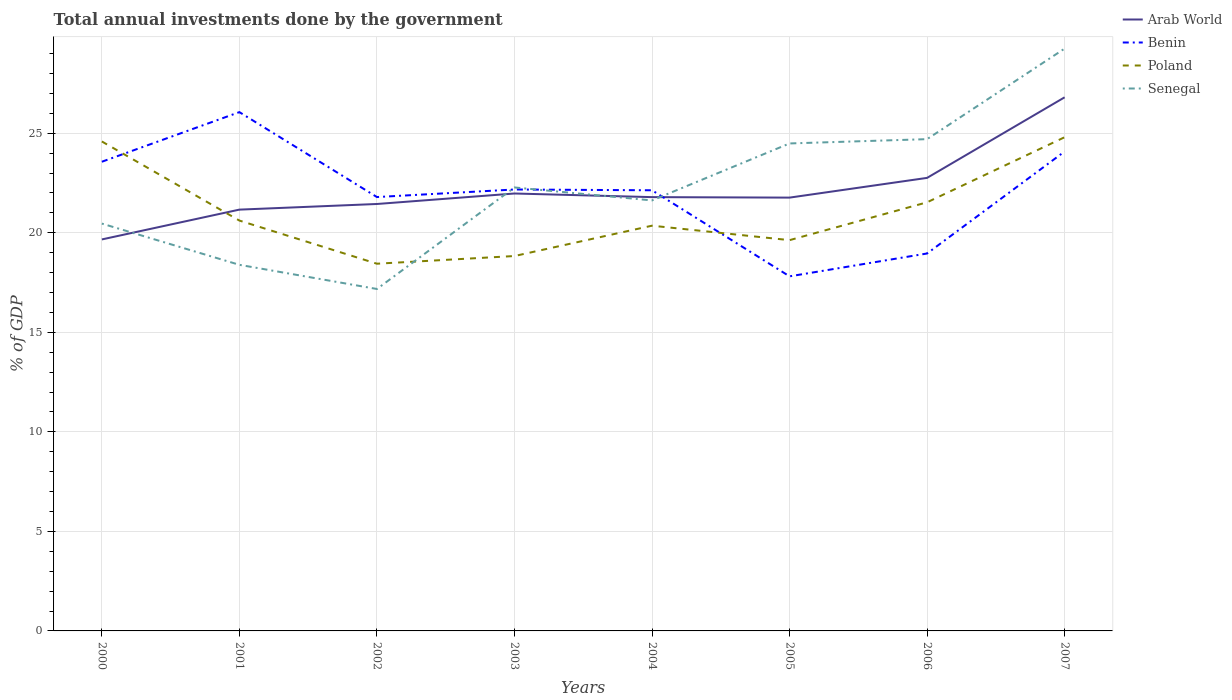Across all years, what is the maximum total annual investments done by the government in Benin?
Offer a very short reply. 17.81. In which year was the total annual investments done by the government in Arab World maximum?
Your answer should be compact. 2000. What is the total total annual investments done by the government in Poland in the graph?
Ensure brevity in your answer.  -3.09. What is the difference between the highest and the second highest total annual investments done by the government in Arab World?
Make the answer very short. 7.14. What is the difference between the highest and the lowest total annual investments done by the government in Senegal?
Offer a terse response. 3. How many years are there in the graph?
Ensure brevity in your answer.  8. What is the difference between two consecutive major ticks on the Y-axis?
Provide a short and direct response. 5. Are the values on the major ticks of Y-axis written in scientific E-notation?
Make the answer very short. No. What is the title of the graph?
Your response must be concise. Total annual investments done by the government. What is the label or title of the X-axis?
Offer a terse response. Years. What is the label or title of the Y-axis?
Your answer should be compact. % of GDP. What is the % of GDP of Arab World in 2000?
Offer a very short reply. 19.67. What is the % of GDP in Benin in 2000?
Ensure brevity in your answer.  23.57. What is the % of GDP of Poland in 2000?
Your response must be concise. 24.59. What is the % of GDP in Senegal in 2000?
Keep it short and to the point. 20.46. What is the % of GDP of Arab World in 2001?
Give a very brief answer. 21.16. What is the % of GDP of Benin in 2001?
Your answer should be compact. 26.06. What is the % of GDP in Poland in 2001?
Provide a short and direct response. 20.61. What is the % of GDP of Senegal in 2001?
Ensure brevity in your answer.  18.39. What is the % of GDP of Arab World in 2002?
Make the answer very short. 21.45. What is the % of GDP of Benin in 2002?
Your answer should be compact. 21.79. What is the % of GDP of Poland in 2002?
Ensure brevity in your answer.  18.45. What is the % of GDP of Senegal in 2002?
Keep it short and to the point. 17.18. What is the % of GDP of Arab World in 2003?
Make the answer very short. 21.97. What is the % of GDP in Benin in 2003?
Provide a short and direct response. 22.17. What is the % of GDP of Poland in 2003?
Keep it short and to the point. 18.83. What is the % of GDP of Senegal in 2003?
Make the answer very short. 22.28. What is the % of GDP in Arab World in 2004?
Offer a very short reply. 21.79. What is the % of GDP in Benin in 2004?
Provide a short and direct response. 22.13. What is the % of GDP of Poland in 2004?
Your response must be concise. 20.36. What is the % of GDP in Senegal in 2004?
Provide a short and direct response. 21.63. What is the % of GDP of Arab World in 2005?
Ensure brevity in your answer.  21.77. What is the % of GDP of Benin in 2005?
Give a very brief answer. 17.81. What is the % of GDP of Poland in 2005?
Keep it short and to the point. 19.63. What is the % of GDP of Senegal in 2005?
Give a very brief answer. 24.49. What is the % of GDP in Arab World in 2006?
Your response must be concise. 22.76. What is the % of GDP of Benin in 2006?
Provide a short and direct response. 18.96. What is the % of GDP in Poland in 2006?
Keep it short and to the point. 21.53. What is the % of GDP in Senegal in 2006?
Your response must be concise. 24.7. What is the % of GDP of Arab World in 2007?
Your response must be concise. 26.8. What is the % of GDP of Benin in 2007?
Your response must be concise. 24.08. What is the % of GDP in Poland in 2007?
Provide a succinct answer. 24.8. What is the % of GDP of Senegal in 2007?
Your answer should be very brief. 29.25. Across all years, what is the maximum % of GDP of Arab World?
Ensure brevity in your answer.  26.8. Across all years, what is the maximum % of GDP of Benin?
Your response must be concise. 26.06. Across all years, what is the maximum % of GDP in Poland?
Offer a very short reply. 24.8. Across all years, what is the maximum % of GDP in Senegal?
Offer a terse response. 29.25. Across all years, what is the minimum % of GDP in Arab World?
Give a very brief answer. 19.67. Across all years, what is the minimum % of GDP in Benin?
Provide a succinct answer. 17.81. Across all years, what is the minimum % of GDP of Poland?
Give a very brief answer. 18.45. Across all years, what is the minimum % of GDP of Senegal?
Your answer should be compact. 17.18. What is the total % of GDP of Arab World in the graph?
Offer a terse response. 177.36. What is the total % of GDP of Benin in the graph?
Give a very brief answer. 176.58. What is the total % of GDP in Poland in the graph?
Give a very brief answer. 168.79. What is the total % of GDP of Senegal in the graph?
Provide a succinct answer. 178.37. What is the difference between the % of GDP in Arab World in 2000 and that in 2001?
Provide a short and direct response. -1.5. What is the difference between the % of GDP of Benin in 2000 and that in 2001?
Offer a terse response. -2.49. What is the difference between the % of GDP of Poland in 2000 and that in 2001?
Your answer should be very brief. 3.97. What is the difference between the % of GDP of Senegal in 2000 and that in 2001?
Offer a terse response. 2.07. What is the difference between the % of GDP in Arab World in 2000 and that in 2002?
Ensure brevity in your answer.  -1.78. What is the difference between the % of GDP in Benin in 2000 and that in 2002?
Provide a succinct answer. 1.77. What is the difference between the % of GDP of Poland in 2000 and that in 2002?
Keep it short and to the point. 6.14. What is the difference between the % of GDP of Senegal in 2000 and that in 2002?
Give a very brief answer. 3.29. What is the difference between the % of GDP in Arab World in 2000 and that in 2003?
Offer a very short reply. -2.31. What is the difference between the % of GDP of Benin in 2000 and that in 2003?
Offer a terse response. 1.39. What is the difference between the % of GDP in Poland in 2000 and that in 2003?
Your answer should be very brief. 5.75. What is the difference between the % of GDP in Senegal in 2000 and that in 2003?
Make the answer very short. -1.81. What is the difference between the % of GDP of Arab World in 2000 and that in 2004?
Your answer should be compact. -2.12. What is the difference between the % of GDP of Benin in 2000 and that in 2004?
Your response must be concise. 1.43. What is the difference between the % of GDP in Poland in 2000 and that in 2004?
Your answer should be compact. 4.23. What is the difference between the % of GDP of Senegal in 2000 and that in 2004?
Offer a very short reply. -1.16. What is the difference between the % of GDP in Arab World in 2000 and that in 2005?
Ensure brevity in your answer.  -2.1. What is the difference between the % of GDP in Benin in 2000 and that in 2005?
Your response must be concise. 5.76. What is the difference between the % of GDP of Poland in 2000 and that in 2005?
Ensure brevity in your answer.  4.96. What is the difference between the % of GDP in Senegal in 2000 and that in 2005?
Your answer should be compact. -4.03. What is the difference between the % of GDP in Arab World in 2000 and that in 2006?
Make the answer very short. -3.09. What is the difference between the % of GDP in Benin in 2000 and that in 2006?
Make the answer very short. 4.61. What is the difference between the % of GDP in Poland in 2000 and that in 2006?
Offer a very short reply. 3.06. What is the difference between the % of GDP in Senegal in 2000 and that in 2006?
Provide a short and direct response. -4.24. What is the difference between the % of GDP in Arab World in 2000 and that in 2007?
Provide a short and direct response. -7.14. What is the difference between the % of GDP in Benin in 2000 and that in 2007?
Your answer should be compact. -0.51. What is the difference between the % of GDP of Poland in 2000 and that in 2007?
Keep it short and to the point. -0.21. What is the difference between the % of GDP in Senegal in 2000 and that in 2007?
Your answer should be compact. -8.79. What is the difference between the % of GDP of Arab World in 2001 and that in 2002?
Provide a succinct answer. -0.28. What is the difference between the % of GDP of Benin in 2001 and that in 2002?
Your response must be concise. 4.27. What is the difference between the % of GDP of Poland in 2001 and that in 2002?
Offer a very short reply. 2.17. What is the difference between the % of GDP of Senegal in 2001 and that in 2002?
Keep it short and to the point. 1.21. What is the difference between the % of GDP of Arab World in 2001 and that in 2003?
Offer a terse response. -0.81. What is the difference between the % of GDP of Benin in 2001 and that in 2003?
Offer a terse response. 3.89. What is the difference between the % of GDP of Poland in 2001 and that in 2003?
Your answer should be very brief. 1.78. What is the difference between the % of GDP of Senegal in 2001 and that in 2003?
Ensure brevity in your answer.  -3.89. What is the difference between the % of GDP in Arab World in 2001 and that in 2004?
Keep it short and to the point. -0.63. What is the difference between the % of GDP of Benin in 2001 and that in 2004?
Keep it short and to the point. 3.93. What is the difference between the % of GDP in Poland in 2001 and that in 2004?
Ensure brevity in your answer.  0.26. What is the difference between the % of GDP of Senegal in 2001 and that in 2004?
Ensure brevity in your answer.  -3.24. What is the difference between the % of GDP of Arab World in 2001 and that in 2005?
Provide a succinct answer. -0.6. What is the difference between the % of GDP of Benin in 2001 and that in 2005?
Make the answer very short. 8.25. What is the difference between the % of GDP of Poland in 2001 and that in 2005?
Provide a short and direct response. 0.98. What is the difference between the % of GDP in Senegal in 2001 and that in 2005?
Offer a terse response. -6.1. What is the difference between the % of GDP of Arab World in 2001 and that in 2006?
Keep it short and to the point. -1.59. What is the difference between the % of GDP of Benin in 2001 and that in 2006?
Offer a terse response. 7.1. What is the difference between the % of GDP of Poland in 2001 and that in 2006?
Offer a terse response. -0.92. What is the difference between the % of GDP of Senegal in 2001 and that in 2006?
Keep it short and to the point. -6.31. What is the difference between the % of GDP of Arab World in 2001 and that in 2007?
Your response must be concise. -5.64. What is the difference between the % of GDP of Benin in 2001 and that in 2007?
Give a very brief answer. 1.98. What is the difference between the % of GDP in Poland in 2001 and that in 2007?
Provide a short and direct response. -4.19. What is the difference between the % of GDP of Senegal in 2001 and that in 2007?
Give a very brief answer. -10.86. What is the difference between the % of GDP in Arab World in 2002 and that in 2003?
Offer a terse response. -0.53. What is the difference between the % of GDP in Benin in 2002 and that in 2003?
Provide a succinct answer. -0.38. What is the difference between the % of GDP of Poland in 2002 and that in 2003?
Offer a terse response. -0.39. What is the difference between the % of GDP of Senegal in 2002 and that in 2003?
Keep it short and to the point. -5.1. What is the difference between the % of GDP in Arab World in 2002 and that in 2004?
Offer a very short reply. -0.34. What is the difference between the % of GDP in Benin in 2002 and that in 2004?
Give a very brief answer. -0.34. What is the difference between the % of GDP of Poland in 2002 and that in 2004?
Your answer should be compact. -1.91. What is the difference between the % of GDP in Senegal in 2002 and that in 2004?
Make the answer very short. -4.45. What is the difference between the % of GDP in Arab World in 2002 and that in 2005?
Your response must be concise. -0.32. What is the difference between the % of GDP of Benin in 2002 and that in 2005?
Provide a succinct answer. 3.98. What is the difference between the % of GDP in Poland in 2002 and that in 2005?
Your answer should be very brief. -1.18. What is the difference between the % of GDP of Senegal in 2002 and that in 2005?
Your answer should be very brief. -7.31. What is the difference between the % of GDP of Arab World in 2002 and that in 2006?
Give a very brief answer. -1.31. What is the difference between the % of GDP of Benin in 2002 and that in 2006?
Your answer should be very brief. 2.83. What is the difference between the % of GDP in Poland in 2002 and that in 2006?
Offer a very short reply. -3.09. What is the difference between the % of GDP of Senegal in 2002 and that in 2006?
Make the answer very short. -7.53. What is the difference between the % of GDP in Arab World in 2002 and that in 2007?
Offer a very short reply. -5.36. What is the difference between the % of GDP of Benin in 2002 and that in 2007?
Keep it short and to the point. -2.29. What is the difference between the % of GDP in Poland in 2002 and that in 2007?
Keep it short and to the point. -6.35. What is the difference between the % of GDP of Senegal in 2002 and that in 2007?
Provide a succinct answer. -12.08. What is the difference between the % of GDP in Arab World in 2003 and that in 2004?
Provide a succinct answer. 0.18. What is the difference between the % of GDP in Benin in 2003 and that in 2004?
Offer a very short reply. 0.04. What is the difference between the % of GDP in Poland in 2003 and that in 2004?
Provide a succinct answer. -1.52. What is the difference between the % of GDP in Senegal in 2003 and that in 2004?
Provide a succinct answer. 0.65. What is the difference between the % of GDP of Arab World in 2003 and that in 2005?
Keep it short and to the point. 0.21. What is the difference between the % of GDP in Benin in 2003 and that in 2005?
Keep it short and to the point. 4.36. What is the difference between the % of GDP in Poland in 2003 and that in 2005?
Make the answer very short. -0.8. What is the difference between the % of GDP in Senegal in 2003 and that in 2005?
Provide a short and direct response. -2.21. What is the difference between the % of GDP in Arab World in 2003 and that in 2006?
Give a very brief answer. -0.78. What is the difference between the % of GDP in Benin in 2003 and that in 2006?
Ensure brevity in your answer.  3.21. What is the difference between the % of GDP in Poland in 2003 and that in 2006?
Provide a succinct answer. -2.7. What is the difference between the % of GDP in Senegal in 2003 and that in 2006?
Offer a terse response. -2.43. What is the difference between the % of GDP in Arab World in 2003 and that in 2007?
Offer a terse response. -4.83. What is the difference between the % of GDP of Benin in 2003 and that in 2007?
Provide a short and direct response. -1.91. What is the difference between the % of GDP of Poland in 2003 and that in 2007?
Ensure brevity in your answer.  -5.97. What is the difference between the % of GDP of Senegal in 2003 and that in 2007?
Make the answer very short. -6.98. What is the difference between the % of GDP of Arab World in 2004 and that in 2005?
Your response must be concise. 0.02. What is the difference between the % of GDP in Benin in 2004 and that in 2005?
Give a very brief answer. 4.32. What is the difference between the % of GDP of Poland in 2004 and that in 2005?
Your answer should be compact. 0.73. What is the difference between the % of GDP of Senegal in 2004 and that in 2005?
Give a very brief answer. -2.86. What is the difference between the % of GDP of Arab World in 2004 and that in 2006?
Provide a short and direct response. -0.97. What is the difference between the % of GDP of Benin in 2004 and that in 2006?
Your response must be concise. 3.17. What is the difference between the % of GDP of Poland in 2004 and that in 2006?
Your answer should be very brief. -1.18. What is the difference between the % of GDP in Senegal in 2004 and that in 2006?
Your answer should be compact. -3.08. What is the difference between the % of GDP in Arab World in 2004 and that in 2007?
Provide a succinct answer. -5.01. What is the difference between the % of GDP of Benin in 2004 and that in 2007?
Keep it short and to the point. -1.95. What is the difference between the % of GDP of Poland in 2004 and that in 2007?
Ensure brevity in your answer.  -4.44. What is the difference between the % of GDP in Senegal in 2004 and that in 2007?
Provide a short and direct response. -7.63. What is the difference between the % of GDP in Arab World in 2005 and that in 2006?
Make the answer very short. -0.99. What is the difference between the % of GDP in Benin in 2005 and that in 2006?
Make the answer very short. -1.15. What is the difference between the % of GDP in Poland in 2005 and that in 2006?
Ensure brevity in your answer.  -1.9. What is the difference between the % of GDP of Senegal in 2005 and that in 2006?
Give a very brief answer. -0.22. What is the difference between the % of GDP in Arab World in 2005 and that in 2007?
Your response must be concise. -5.04. What is the difference between the % of GDP in Benin in 2005 and that in 2007?
Make the answer very short. -6.27. What is the difference between the % of GDP in Poland in 2005 and that in 2007?
Provide a short and direct response. -5.17. What is the difference between the % of GDP of Senegal in 2005 and that in 2007?
Your response must be concise. -4.76. What is the difference between the % of GDP in Arab World in 2006 and that in 2007?
Offer a very short reply. -4.05. What is the difference between the % of GDP in Benin in 2006 and that in 2007?
Offer a very short reply. -5.12. What is the difference between the % of GDP of Poland in 2006 and that in 2007?
Make the answer very short. -3.27. What is the difference between the % of GDP of Senegal in 2006 and that in 2007?
Make the answer very short. -4.55. What is the difference between the % of GDP in Arab World in 2000 and the % of GDP in Benin in 2001?
Your response must be concise. -6.39. What is the difference between the % of GDP in Arab World in 2000 and the % of GDP in Poland in 2001?
Provide a succinct answer. -0.95. What is the difference between the % of GDP in Arab World in 2000 and the % of GDP in Senegal in 2001?
Keep it short and to the point. 1.28. What is the difference between the % of GDP of Benin in 2000 and the % of GDP of Poland in 2001?
Your answer should be very brief. 2.95. What is the difference between the % of GDP of Benin in 2000 and the % of GDP of Senegal in 2001?
Make the answer very short. 5.18. What is the difference between the % of GDP in Poland in 2000 and the % of GDP in Senegal in 2001?
Ensure brevity in your answer.  6.2. What is the difference between the % of GDP of Arab World in 2000 and the % of GDP of Benin in 2002?
Your answer should be compact. -2.13. What is the difference between the % of GDP in Arab World in 2000 and the % of GDP in Poland in 2002?
Keep it short and to the point. 1.22. What is the difference between the % of GDP in Arab World in 2000 and the % of GDP in Senegal in 2002?
Make the answer very short. 2.49. What is the difference between the % of GDP in Benin in 2000 and the % of GDP in Poland in 2002?
Provide a short and direct response. 5.12. What is the difference between the % of GDP in Benin in 2000 and the % of GDP in Senegal in 2002?
Your answer should be compact. 6.39. What is the difference between the % of GDP in Poland in 2000 and the % of GDP in Senegal in 2002?
Your response must be concise. 7.41. What is the difference between the % of GDP of Arab World in 2000 and the % of GDP of Benin in 2003?
Your answer should be very brief. -2.51. What is the difference between the % of GDP of Arab World in 2000 and the % of GDP of Poland in 2003?
Ensure brevity in your answer.  0.83. What is the difference between the % of GDP of Arab World in 2000 and the % of GDP of Senegal in 2003?
Provide a short and direct response. -2.61. What is the difference between the % of GDP in Benin in 2000 and the % of GDP in Poland in 2003?
Your response must be concise. 4.74. What is the difference between the % of GDP of Benin in 2000 and the % of GDP of Senegal in 2003?
Offer a very short reply. 1.29. What is the difference between the % of GDP of Poland in 2000 and the % of GDP of Senegal in 2003?
Your response must be concise. 2.31. What is the difference between the % of GDP of Arab World in 2000 and the % of GDP of Benin in 2004?
Make the answer very short. -2.47. What is the difference between the % of GDP of Arab World in 2000 and the % of GDP of Poland in 2004?
Your answer should be compact. -0.69. What is the difference between the % of GDP of Arab World in 2000 and the % of GDP of Senegal in 2004?
Offer a terse response. -1.96. What is the difference between the % of GDP in Benin in 2000 and the % of GDP in Poland in 2004?
Make the answer very short. 3.21. What is the difference between the % of GDP in Benin in 2000 and the % of GDP in Senegal in 2004?
Make the answer very short. 1.94. What is the difference between the % of GDP of Poland in 2000 and the % of GDP of Senegal in 2004?
Give a very brief answer. 2.96. What is the difference between the % of GDP of Arab World in 2000 and the % of GDP of Benin in 2005?
Offer a terse response. 1.85. What is the difference between the % of GDP of Arab World in 2000 and the % of GDP of Poland in 2005?
Keep it short and to the point. 0.04. What is the difference between the % of GDP in Arab World in 2000 and the % of GDP in Senegal in 2005?
Your response must be concise. -4.82. What is the difference between the % of GDP in Benin in 2000 and the % of GDP in Poland in 2005?
Keep it short and to the point. 3.94. What is the difference between the % of GDP of Benin in 2000 and the % of GDP of Senegal in 2005?
Your answer should be compact. -0.92. What is the difference between the % of GDP of Poland in 2000 and the % of GDP of Senegal in 2005?
Provide a short and direct response. 0.1. What is the difference between the % of GDP of Arab World in 2000 and the % of GDP of Benin in 2006?
Your response must be concise. 0.71. What is the difference between the % of GDP of Arab World in 2000 and the % of GDP of Poland in 2006?
Provide a short and direct response. -1.87. What is the difference between the % of GDP of Arab World in 2000 and the % of GDP of Senegal in 2006?
Offer a very short reply. -5.04. What is the difference between the % of GDP of Benin in 2000 and the % of GDP of Poland in 2006?
Make the answer very short. 2.04. What is the difference between the % of GDP in Benin in 2000 and the % of GDP in Senegal in 2006?
Your response must be concise. -1.14. What is the difference between the % of GDP of Poland in 2000 and the % of GDP of Senegal in 2006?
Your answer should be compact. -0.12. What is the difference between the % of GDP of Arab World in 2000 and the % of GDP of Benin in 2007?
Your response must be concise. -4.42. What is the difference between the % of GDP in Arab World in 2000 and the % of GDP in Poland in 2007?
Give a very brief answer. -5.13. What is the difference between the % of GDP of Arab World in 2000 and the % of GDP of Senegal in 2007?
Give a very brief answer. -9.59. What is the difference between the % of GDP of Benin in 2000 and the % of GDP of Poland in 2007?
Your answer should be very brief. -1.23. What is the difference between the % of GDP of Benin in 2000 and the % of GDP of Senegal in 2007?
Offer a very short reply. -5.68. What is the difference between the % of GDP of Poland in 2000 and the % of GDP of Senegal in 2007?
Your response must be concise. -4.67. What is the difference between the % of GDP of Arab World in 2001 and the % of GDP of Benin in 2002?
Your answer should be very brief. -0.63. What is the difference between the % of GDP in Arab World in 2001 and the % of GDP in Poland in 2002?
Ensure brevity in your answer.  2.72. What is the difference between the % of GDP of Arab World in 2001 and the % of GDP of Senegal in 2002?
Your answer should be very brief. 3.99. What is the difference between the % of GDP in Benin in 2001 and the % of GDP in Poland in 2002?
Make the answer very short. 7.61. What is the difference between the % of GDP of Benin in 2001 and the % of GDP of Senegal in 2002?
Offer a terse response. 8.88. What is the difference between the % of GDP in Poland in 2001 and the % of GDP in Senegal in 2002?
Your answer should be compact. 3.44. What is the difference between the % of GDP in Arab World in 2001 and the % of GDP in Benin in 2003?
Make the answer very short. -1.01. What is the difference between the % of GDP in Arab World in 2001 and the % of GDP in Poland in 2003?
Your answer should be compact. 2.33. What is the difference between the % of GDP in Arab World in 2001 and the % of GDP in Senegal in 2003?
Provide a succinct answer. -1.11. What is the difference between the % of GDP of Benin in 2001 and the % of GDP of Poland in 2003?
Make the answer very short. 7.23. What is the difference between the % of GDP of Benin in 2001 and the % of GDP of Senegal in 2003?
Your response must be concise. 3.78. What is the difference between the % of GDP in Poland in 2001 and the % of GDP in Senegal in 2003?
Give a very brief answer. -1.66. What is the difference between the % of GDP in Arab World in 2001 and the % of GDP in Benin in 2004?
Give a very brief answer. -0.97. What is the difference between the % of GDP of Arab World in 2001 and the % of GDP of Poland in 2004?
Your answer should be compact. 0.81. What is the difference between the % of GDP of Arab World in 2001 and the % of GDP of Senegal in 2004?
Keep it short and to the point. -0.46. What is the difference between the % of GDP in Benin in 2001 and the % of GDP in Poland in 2004?
Give a very brief answer. 5.7. What is the difference between the % of GDP of Benin in 2001 and the % of GDP of Senegal in 2004?
Your answer should be compact. 4.43. What is the difference between the % of GDP of Poland in 2001 and the % of GDP of Senegal in 2004?
Your response must be concise. -1.01. What is the difference between the % of GDP in Arab World in 2001 and the % of GDP in Benin in 2005?
Provide a succinct answer. 3.35. What is the difference between the % of GDP of Arab World in 2001 and the % of GDP of Poland in 2005?
Offer a terse response. 1.53. What is the difference between the % of GDP of Arab World in 2001 and the % of GDP of Senegal in 2005?
Provide a succinct answer. -3.32. What is the difference between the % of GDP in Benin in 2001 and the % of GDP in Poland in 2005?
Your answer should be very brief. 6.43. What is the difference between the % of GDP of Benin in 2001 and the % of GDP of Senegal in 2005?
Keep it short and to the point. 1.57. What is the difference between the % of GDP of Poland in 2001 and the % of GDP of Senegal in 2005?
Ensure brevity in your answer.  -3.87. What is the difference between the % of GDP of Arab World in 2001 and the % of GDP of Benin in 2006?
Ensure brevity in your answer.  2.2. What is the difference between the % of GDP of Arab World in 2001 and the % of GDP of Poland in 2006?
Your answer should be compact. -0.37. What is the difference between the % of GDP of Arab World in 2001 and the % of GDP of Senegal in 2006?
Offer a terse response. -3.54. What is the difference between the % of GDP of Benin in 2001 and the % of GDP of Poland in 2006?
Provide a short and direct response. 4.53. What is the difference between the % of GDP in Benin in 2001 and the % of GDP in Senegal in 2006?
Give a very brief answer. 1.36. What is the difference between the % of GDP of Poland in 2001 and the % of GDP of Senegal in 2006?
Your response must be concise. -4.09. What is the difference between the % of GDP in Arab World in 2001 and the % of GDP in Benin in 2007?
Keep it short and to the point. -2.92. What is the difference between the % of GDP in Arab World in 2001 and the % of GDP in Poland in 2007?
Your answer should be very brief. -3.64. What is the difference between the % of GDP in Arab World in 2001 and the % of GDP in Senegal in 2007?
Offer a very short reply. -8.09. What is the difference between the % of GDP in Benin in 2001 and the % of GDP in Poland in 2007?
Your response must be concise. 1.26. What is the difference between the % of GDP in Benin in 2001 and the % of GDP in Senegal in 2007?
Ensure brevity in your answer.  -3.19. What is the difference between the % of GDP in Poland in 2001 and the % of GDP in Senegal in 2007?
Make the answer very short. -8.64. What is the difference between the % of GDP in Arab World in 2002 and the % of GDP in Benin in 2003?
Make the answer very short. -0.73. What is the difference between the % of GDP in Arab World in 2002 and the % of GDP in Poland in 2003?
Provide a succinct answer. 2.61. What is the difference between the % of GDP of Arab World in 2002 and the % of GDP of Senegal in 2003?
Your response must be concise. -0.83. What is the difference between the % of GDP of Benin in 2002 and the % of GDP of Poland in 2003?
Give a very brief answer. 2.96. What is the difference between the % of GDP of Benin in 2002 and the % of GDP of Senegal in 2003?
Give a very brief answer. -0.48. What is the difference between the % of GDP in Poland in 2002 and the % of GDP in Senegal in 2003?
Provide a short and direct response. -3.83. What is the difference between the % of GDP of Arab World in 2002 and the % of GDP of Benin in 2004?
Provide a succinct answer. -0.69. What is the difference between the % of GDP in Arab World in 2002 and the % of GDP in Poland in 2004?
Your answer should be very brief. 1.09. What is the difference between the % of GDP in Arab World in 2002 and the % of GDP in Senegal in 2004?
Provide a succinct answer. -0.18. What is the difference between the % of GDP of Benin in 2002 and the % of GDP of Poland in 2004?
Your answer should be compact. 1.44. What is the difference between the % of GDP in Benin in 2002 and the % of GDP in Senegal in 2004?
Keep it short and to the point. 0.17. What is the difference between the % of GDP of Poland in 2002 and the % of GDP of Senegal in 2004?
Ensure brevity in your answer.  -3.18. What is the difference between the % of GDP of Arab World in 2002 and the % of GDP of Benin in 2005?
Give a very brief answer. 3.63. What is the difference between the % of GDP in Arab World in 2002 and the % of GDP in Poland in 2005?
Give a very brief answer. 1.82. What is the difference between the % of GDP of Arab World in 2002 and the % of GDP of Senegal in 2005?
Offer a terse response. -3.04. What is the difference between the % of GDP in Benin in 2002 and the % of GDP in Poland in 2005?
Your answer should be compact. 2.16. What is the difference between the % of GDP in Benin in 2002 and the % of GDP in Senegal in 2005?
Your answer should be very brief. -2.69. What is the difference between the % of GDP of Poland in 2002 and the % of GDP of Senegal in 2005?
Offer a terse response. -6.04. What is the difference between the % of GDP in Arab World in 2002 and the % of GDP in Benin in 2006?
Your answer should be very brief. 2.49. What is the difference between the % of GDP of Arab World in 2002 and the % of GDP of Poland in 2006?
Provide a short and direct response. -0.09. What is the difference between the % of GDP in Arab World in 2002 and the % of GDP in Senegal in 2006?
Your answer should be very brief. -3.26. What is the difference between the % of GDP of Benin in 2002 and the % of GDP of Poland in 2006?
Offer a terse response. 0.26. What is the difference between the % of GDP of Benin in 2002 and the % of GDP of Senegal in 2006?
Make the answer very short. -2.91. What is the difference between the % of GDP of Poland in 2002 and the % of GDP of Senegal in 2006?
Offer a very short reply. -6.26. What is the difference between the % of GDP in Arab World in 2002 and the % of GDP in Benin in 2007?
Give a very brief answer. -2.64. What is the difference between the % of GDP in Arab World in 2002 and the % of GDP in Poland in 2007?
Your answer should be very brief. -3.35. What is the difference between the % of GDP of Arab World in 2002 and the % of GDP of Senegal in 2007?
Offer a terse response. -7.81. What is the difference between the % of GDP of Benin in 2002 and the % of GDP of Poland in 2007?
Offer a terse response. -3.01. What is the difference between the % of GDP of Benin in 2002 and the % of GDP of Senegal in 2007?
Provide a short and direct response. -7.46. What is the difference between the % of GDP of Poland in 2002 and the % of GDP of Senegal in 2007?
Provide a succinct answer. -10.81. What is the difference between the % of GDP in Arab World in 2003 and the % of GDP in Benin in 2004?
Your answer should be very brief. -0.16. What is the difference between the % of GDP in Arab World in 2003 and the % of GDP in Poland in 2004?
Make the answer very short. 1.62. What is the difference between the % of GDP in Arab World in 2003 and the % of GDP in Senegal in 2004?
Keep it short and to the point. 0.35. What is the difference between the % of GDP of Benin in 2003 and the % of GDP of Poland in 2004?
Give a very brief answer. 1.82. What is the difference between the % of GDP in Benin in 2003 and the % of GDP in Senegal in 2004?
Provide a succinct answer. 0.55. What is the difference between the % of GDP of Poland in 2003 and the % of GDP of Senegal in 2004?
Your answer should be compact. -2.79. What is the difference between the % of GDP in Arab World in 2003 and the % of GDP in Benin in 2005?
Offer a terse response. 4.16. What is the difference between the % of GDP of Arab World in 2003 and the % of GDP of Poland in 2005?
Ensure brevity in your answer.  2.34. What is the difference between the % of GDP in Arab World in 2003 and the % of GDP in Senegal in 2005?
Provide a succinct answer. -2.51. What is the difference between the % of GDP in Benin in 2003 and the % of GDP in Poland in 2005?
Your answer should be compact. 2.54. What is the difference between the % of GDP of Benin in 2003 and the % of GDP of Senegal in 2005?
Give a very brief answer. -2.31. What is the difference between the % of GDP in Poland in 2003 and the % of GDP in Senegal in 2005?
Your response must be concise. -5.65. What is the difference between the % of GDP of Arab World in 2003 and the % of GDP of Benin in 2006?
Your answer should be very brief. 3.01. What is the difference between the % of GDP of Arab World in 2003 and the % of GDP of Poland in 2006?
Provide a short and direct response. 0.44. What is the difference between the % of GDP of Arab World in 2003 and the % of GDP of Senegal in 2006?
Ensure brevity in your answer.  -2.73. What is the difference between the % of GDP of Benin in 2003 and the % of GDP of Poland in 2006?
Provide a succinct answer. 0.64. What is the difference between the % of GDP of Benin in 2003 and the % of GDP of Senegal in 2006?
Provide a short and direct response. -2.53. What is the difference between the % of GDP of Poland in 2003 and the % of GDP of Senegal in 2006?
Make the answer very short. -5.87. What is the difference between the % of GDP of Arab World in 2003 and the % of GDP of Benin in 2007?
Offer a very short reply. -2.11. What is the difference between the % of GDP in Arab World in 2003 and the % of GDP in Poland in 2007?
Provide a succinct answer. -2.83. What is the difference between the % of GDP in Arab World in 2003 and the % of GDP in Senegal in 2007?
Provide a short and direct response. -7.28. What is the difference between the % of GDP of Benin in 2003 and the % of GDP of Poland in 2007?
Your response must be concise. -2.63. What is the difference between the % of GDP of Benin in 2003 and the % of GDP of Senegal in 2007?
Provide a succinct answer. -7.08. What is the difference between the % of GDP in Poland in 2003 and the % of GDP in Senegal in 2007?
Your answer should be compact. -10.42. What is the difference between the % of GDP of Arab World in 2004 and the % of GDP of Benin in 2005?
Ensure brevity in your answer.  3.98. What is the difference between the % of GDP in Arab World in 2004 and the % of GDP in Poland in 2005?
Your response must be concise. 2.16. What is the difference between the % of GDP in Arab World in 2004 and the % of GDP in Senegal in 2005?
Offer a very short reply. -2.7. What is the difference between the % of GDP of Benin in 2004 and the % of GDP of Poland in 2005?
Make the answer very short. 2.5. What is the difference between the % of GDP in Benin in 2004 and the % of GDP in Senegal in 2005?
Your answer should be compact. -2.35. What is the difference between the % of GDP in Poland in 2004 and the % of GDP in Senegal in 2005?
Offer a very short reply. -4.13. What is the difference between the % of GDP in Arab World in 2004 and the % of GDP in Benin in 2006?
Your answer should be compact. 2.83. What is the difference between the % of GDP of Arab World in 2004 and the % of GDP of Poland in 2006?
Your response must be concise. 0.26. What is the difference between the % of GDP of Arab World in 2004 and the % of GDP of Senegal in 2006?
Offer a terse response. -2.91. What is the difference between the % of GDP of Benin in 2004 and the % of GDP of Poland in 2006?
Make the answer very short. 0.6. What is the difference between the % of GDP in Benin in 2004 and the % of GDP in Senegal in 2006?
Make the answer very short. -2.57. What is the difference between the % of GDP in Poland in 2004 and the % of GDP in Senegal in 2006?
Offer a very short reply. -4.35. What is the difference between the % of GDP of Arab World in 2004 and the % of GDP of Benin in 2007?
Give a very brief answer. -2.29. What is the difference between the % of GDP of Arab World in 2004 and the % of GDP of Poland in 2007?
Offer a very short reply. -3.01. What is the difference between the % of GDP in Arab World in 2004 and the % of GDP in Senegal in 2007?
Provide a succinct answer. -7.46. What is the difference between the % of GDP in Benin in 2004 and the % of GDP in Poland in 2007?
Your answer should be very brief. -2.67. What is the difference between the % of GDP of Benin in 2004 and the % of GDP of Senegal in 2007?
Your answer should be compact. -7.12. What is the difference between the % of GDP in Poland in 2004 and the % of GDP in Senegal in 2007?
Offer a very short reply. -8.9. What is the difference between the % of GDP in Arab World in 2005 and the % of GDP in Benin in 2006?
Ensure brevity in your answer.  2.81. What is the difference between the % of GDP in Arab World in 2005 and the % of GDP in Poland in 2006?
Provide a short and direct response. 0.24. What is the difference between the % of GDP of Arab World in 2005 and the % of GDP of Senegal in 2006?
Keep it short and to the point. -2.94. What is the difference between the % of GDP of Benin in 2005 and the % of GDP of Poland in 2006?
Provide a succinct answer. -3.72. What is the difference between the % of GDP of Benin in 2005 and the % of GDP of Senegal in 2006?
Make the answer very short. -6.89. What is the difference between the % of GDP of Poland in 2005 and the % of GDP of Senegal in 2006?
Provide a short and direct response. -5.07. What is the difference between the % of GDP in Arab World in 2005 and the % of GDP in Benin in 2007?
Offer a very short reply. -2.32. What is the difference between the % of GDP of Arab World in 2005 and the % of GDP of Poland in 2007?
Keep it short and to the point. -3.03. What is the difference between the % of GDP in Arab World in 2005 and the % of GDP in Senegal in 2007?
Provide a succinct answer. -7.49. What is the difference between the % of GDP in Benin in 2005 and the % of GDP in Poland in 2007?
Provide a succinct answer. -6.99. What is the difference between the % of GDP in Benin in 2005 and the % of GDP in Senegal in 2007?
Keep it short and to the point. -11.44. What is the difference between the % of GDP in Poland in 2005 and the % of GDP in Senegal in 2007?
Your answer should be compact. -9.62. What is the difference between the % of GDP of Arab World in 2006 and the % of GDP of Benin in 2007?
Keep it short and to the point. -1.33. What is the difference between the % of GDP of Arab World in 2006 and the % of GDP of Poland in 2007?
Your answer should be compact. -2.04. What is the difference between the % of GDP of Arab World in 2006 and the % of GDP of Senegal in 2007?
Your answer should be very brief. -6.49. What is the difference between the % of GDP of Benin in 2006 and the % of GDP of Poland in 2007?
Offer a very short reply. -5.84. What is the difference between the % of GDP in Benin in 2006 and the % of GDP in Senegal in 2007?
Ensure brevity in your answer.  -10.29. What is the difference between the % of GDP of Poland in 2006 and the % of GDP of Senegal in 2007?
Your answer should be compact. -7.72. What is the average % of GDP in Arab World per year?
Provide a short and direct response. 22.17. What is the average % of GDP in Benin per year?
Your answer should be compact. 22.07. What is the average % of GDP of Poland per year?
Provide a succinct answer. 21.1. What is the average % of GDP in Senegal per year?
Your answer should be very brief. 22.3. In the year 2000, what is the difference between the % of GDP of Arab World and % of GDP of Benin?
Your response must be concise. -3.9. In the year 2000, what is the difference between the % of GDP of Arab World and % of GDP of Poland?
Provide a short and direct response. -4.92. In the year 2000, what is the difference between the % of GDP in Arab World and % of GDP in Senegal?
Your response must be concise. -0.8. In the year 2000, what is the difference between the % of GDP in Benin and % of GDP in Poland?
Your response must be concise. -1.02. In the year 2000, what is the difference between the % of GDP of Benin and % of GDP of Senegal?
Make the answer very short. 3.11. In the year 2000, what is the difference between the % of GDP in Poland and % of GDP in Senegal?
Your answer should be very brief. 4.13. In the year 2001, what is the difference between the % of GDP of Arab World and % of GDP of Benin?
Provide a short and direct response. -4.9. In the year 2001, what is the difference between the % of GDP of Arab World and % of GDP of Poland?
Your answer should be compact. 0.55. In the year 2001, what is the difference between the % of GDP in Arab World and % of GDP in Senegal?
Ensure brevity in your answer.  2.77. In the year 2001, what is the difference between the % of GDP of Benin and % of GDP of Poland?
Offer a terse response. 5.45. In the year 2001, what is the difference between the % of GDP of Benin and % of GDP of Senegal?
Your response must be concise. 7.67. In the year 2001, what is the difference between the % of GDP of Poland and % of GDP of Senegal?
Your response must be concise. 2.22. In the year 2002, what is the difference between the % of GDP of Arab World and % of GDP of Benin?
Make the answer very short. -0.35. In the year 2002, what is the difference between the % of GDP of Arab World and % of GDP of Poland?
Give a very brief answer. 3. In the year 2002, what is the difference between the % of GDP in Arab World and % of GDP in Senegal?
Make the answer very short. 4.27. In the year 2002, what is the difference between the % of GDP in Benin and % of GDP in Poland?
Provide a short and direct response. 3.35. In the year 2002, what is the difference between the % of GDP of Benin and % of GDP of Senegal?
Your response must be concise. 4.62. In the year 2002, what is the difference between the % of GDP in Poland and % of GDP in Senegal?
Your answer should be compact. 1.27. In the year 2003, what is the difference between the % of GDP in Arab World and % of GDP in Benin?
Provide a short and direct response. -0.2. In the year 2003, what is the difference between the % of GDP in Arab World and % of GDP in Poland?
Provide a succinct answer. 3.14. In the year 2003, what is the difference between the % of GDP of Arab World and % of GDP of Senegal?
Give a very brief answer. -0.3. In the year 2003, what is the difference between the % of GDP in Benin and % of GDP in Poland?
Your answer should be very brief. 3.34. In the year 2003, what is the difference between the % of GDP in Benin and % of GDP in Senegal?
Offer a terse response. -0.1. In the year 2003, what is the difference between the % of GDP in Poland and % of GDP in Senegal?
Provide a short and direct response. -3.44. In the year 2004, what is the difference between the % of GDP of Arab World and % of GDP of Benin?
Your answer should be very brief. -0.34. In the year 2004, what is the difference between the % of GDP of Arab World and % of GDP of Poland?
Provide a short and direct response. 1.43. In the year 2004, what is the difference between the % of GDP in Arab World and % of GDP in Senegal?
Ensure brevity in your answer.  0.17. In the year 2004, what is the difference between the % of GDP of Benin and % of GDP of Poland?
Offer a very short reply. 1.78. In the year 2004, what is the difference between the % of GDP of Benin and % of GDP of Senegal?
Ensure brevity in your answer.  0.51. In the year 2004, what is the difference between the % of GDP in Poland and % of GDP in Senegal?
Offer a very short reply. -1.27. In the year 2005, what is the difference between the % of GDP in Arab World and % of GDP in Benin?
Keep it short and to the point. 3.95. In the year 2005, what is the difference between the % of GDP of Arab World and % of GDP of Poland?
Your answer should be compact. 2.14. In the year 2005, what is the difference between the % of GDP in Arab World and % of GDP in Senegal?
Ensure brevity in your answer.  -2.72. In the year 2005, what is the difference between the % of GDP of Benin and % of GDP of Poland?
Provide a succinct answer. -1.82. In the year 2005, what is the difference between the % of GDP of Benin and % of GDP of Senegal?
Keep it short and to the point. -6.68. In the year 2005, what is the difference between the % of GDP of Poland and % of GDP of Senegal?
Offer a very short reply. -4.86. In the year 2006, what is the difference between the % of GDP of Arab World and % of GDP of Benin?
Provide a short and direct response. 3.8. In the year 2006, what is the difference between the % of GDP of Arab World and % of GDP of Poland?
Offer a very short reply. 1.23. In the year 2006, what is the difference between the % of GDP of Arab World and % of GDP of Senegal?
Keep it short and to the point. -1.95. In the year 2006, what is the difference between the % of GDP of Benin and % of GDP of Poland?
Make the answer very short. -2.57. In the year 2006, what is the difference between the % of GDP in Benin and % of GDP in Senegal?
Offer a very short reply. -5.74. In the year 2006, what is the difference between the % of GDP of Poland and % of GDP of Senegal?
Your response must be concise. -3.17. In the year 2007, what is the difference between the % of GDP of Arab World and % of GDP of Benin?
Provide a succinct answer. 2.72. In the year 2007, what is the difference between the % of GDP in Arab World and % of GDP in Poland?
Make the answer very short. 2. In the year 2007, what is the difference between the % of GDP in Arab World and % of GDP in Senegal?
Make the answer very short. -2.45. In the year 2007, what is the difference between the % of GDP in Benin and % of GDP in Poland?
Provide a short and direct response. -0.72. In the year 2007, what is the difference between the % of GDP in Benin and % of GDP in Senegal?
Your answer should be very brief. -5.17. In the year 2007, what is the difference between the % of GDP of Poland and % of GDP of Senegal?
Keep it short and to the point. -4.45. What is the ratio of the % of GDP in Arab World in 2000 to that in 2001?
Give a very brief answer. 0.93. What is the ratio of the % of GDP of Benin in 2000 to that in 2001?
Offer a very short reply. 0.9. What is the ratio of the % of GDP in Poland in 2000 to that in 2001?
Offer a very short reply. 1.19. What is the ratio of the % of GDP in Senegal in 2000 to that in 2001?
Offer a terse response. 1.11. What is the ratio of the % of GDP of Arab World in 2000 to that in 2002?
Offer a very short reply. 0.92. What is the ratio of the % of GDP of Benin in 2000 to that in 2002?
Ensure brevity in your answer.  1.08. What is the ratio of the % of GDP of Poland in 2000 to that in 2002?
Provide a succinct answer. 1.33. What is the ratio of the % of GDP in Senegal in 2000 to that in 2002?
Offer a terse response. 1.19. What is the ratio of the % of GDP in Arab World in 2000 to that in 2003?
Offer a very short reply. 0.9. What is the ratio of the % of GDP in Benin in 2000 to that in 2003?
Your answer should be very brief. 1.06. What is the ratio of the % of GDP of Poland in 2000 to that in 2003?
Your answer should be compact. 1.31. What is the ratio of the % of GDP in Senegal in 2000 to that in 2003?
Ensure brevity in your answer.  0.92. What is the ratio of the % of GDP of Arab World in 2000 to that in 2004?
Give a very brief answer. 0.9. What is the ratio of the % of GDP in Benin in 2000 to that in 2004?
Your response must be concise. 1.06. What is the ratio of the % of GDP in Poland in 2000 to that in 2004?
Your answer should be very brief. 1.21. What is the ratio of the % of GDP in Senegal in 2000 to that in 2004?
Make the answer very short. 0.95. What is the ratio of the % of GDP in Arab World in 2000 to that in 2005?
Your response must be concise. 0.9. What is the ratio of the % of GDP in Benin in 2000 to that in 2005?
Your response must be concise. 1.32. What is the ratio of the % of GDP of Poland in 2000 to that in 2005?
Your response must be concise. 1.25. What is the ratio of the % of GDP in Senegal in 2000 to that in 2005?
Keep it short and to the point. 0.84. What is the ratio of the % of GDP in Arab World in 2000 to that in 2006?
Offer a very short reply. 0.86. What is the ratio of the % of GDP in Benin in 2000 to that in 2006?
Keep it short and to the point. 1.24. What is the ratio of the % of GDP of Poland in 2000 to that in 2006?
Give a very brief answer. 1.14. What is the ratio of the % of GDP in Senegal in 2000 to that in 2006?
Give a very brief answer. 0.83. What is the ratio of the % of GDP in Arab World in 2000 to that in 2007?
Ensure brevity in your answer.  0.73. What is the ratio of the % of GDP of Benin in 2000 to that in 2007?
Your response must be concise. 0.98. What is the ratio of the % of GDP of Poland in 2000 to that in 2007?
Provide a succinct answer. 0.99. What is the ratio of the % of GDP of Senegal in 2000 to that in 2007?
Your answer should be very brief. 0.7. What is the ratio of the % of GDP of Arab World in 2001 to that in 2002?
Your response must be concise. 0.99. What is the ratio of the % of GDP of Benin in 2001 to that in 2002?
Make the answer very short. 1.2. What is the ratio of the % of GDP of Poland in 2001 to that in 2002?
Ensure brevity in your answer.  1.12. What is the ratio of the % of GDP in Senegal in 2001 to that in 2002?
Give a very brief answer. 1.07. What is the ratio of the % of GDP in Arab World in 2001 to that in 2003?
Ensure brevity in your answer.  0.96. What is the ratio of the % of GDP of Benin in 2001 to that in 2003?
Your response must be concise. 1.18. What is the ratio of the % of GDP of Poland in 2001 to that in 2003?
Ensure brevity in your answer.  1.09. What is the ratio of the % of GDP of Senegal in 2001 to that in 2003?
Provide a succinct answer. 0.83. What is the ratio of the % of GDP in Arab World in 2001 to that in 2004?
Provide a short and direct response. 0.97. What is the ratio of the % of GDP in Benin in 2001 to that in 2004?
Your response must be concise. 1.18. What is the ratio of the % of GDP of Poland in 2001 to that in 2004?
Make the answer very short. 1.01. What is the ratio of the % of GDP of Senegal in 2001 to that in 2004?
Your answer should be compact. 0.85. What is the ratio of the % of GDP of Arab World in 2001 to that in 2005?
Provide a short and direct response. 0.97. What is the ratio of the % of GDP in Benin in 2001 to that in 2005?
Offer a very short reply. 1.46. What is the ratio of the % of GDP of Poland in 2001 to that in 2005?
Make the answer very short. 1.05. What is the ratio of the % of GDP in Senegal in 2001 to that in 2005?
Offer a terse response. 0.75. What is the ratio of the % of GDP in Arab World in 2001 to that in 2006?
Provide a short and direct response. 0.93. What is the ratio of the % of GDP in Benin in 2001 to that in 2006?
Ensure brevity in your answer.  1.37. What is the ratio of the % of GDP in Poland in 2001 to that in 2006?
Your response must be concise. 0.96. What is the ratio of the % of GDP in Senegal in 2001 to that in 2006?
Keep it short and to the point. 0.74. What is the ratio of the % of GDP in Arab World in 2001 to that in 2007?
Offer a very short reply. 0.79. What is the ratio of the % of GDP of Benin in 2001 to that in 2007?
Provide a succinct answer. 1.08. What is the ratio of the % of GDP of Poland in 2001 to that in 2007?
Provide a short and direct response. 0.83. What is the ratio of the % of GDP in Senegal in 2001 to that in 2007?
Offer a very short reply. 0.63. What is the ratio of the % of GDP in Arab World in 2002 to that in 2003?
Your response must be concise. 0.98. What is the ratio of the % of GDP in Benin in 2002 to that in 2003?
Keep it short and to the point. 0.98. What is the ratio of the % of GDP of Poland in 2002 to that in 2003?
Give a very brief answer. 0.98. What is the ratio of the % of GDP in Senegal in 2002 to that in 2003?
Your answer should be compact. 0.77. What is the ratio of the % of GDP of Arab World in 2002 to that in 2004?
Provide a succinct answer. 0.98. What is the ratio of the % of GDP of Benin in 2002 to that in 2004?
Provide a short and direct response. 0.98. What is the ratio of the % of GDP in Poland in 2002 to that in 2004?
Keep it short and to the point. 0.91. What is the ratio of the % of GDP of Senegal in 2002 to that in 2004?
Your answer should be very brief. 0.79. What is the ratio of the % of GDP of Arab World in 2002 to that in 2005?
Provide a succinct answer. 0.99. What is the ratio of the % of GDP of Benin in 2002 to that in 2005?
Ensure brevity in your answer.  1.22. What is the ratio of the % of GDP in Poland in 2002 to that in 2005?
Your answer should be compact. 0.94. What is the ratio of the % of GDP in Senegal in 2002 to that in 2005?
Keep it short and to the point. 0.7. What is the ratio of the % of GDP of Arab World in 2002 to that in 2006?
Your response must be concise. 0.94. What is the ratio of the % of GDP in Benin in 2002 to that in 2006?
Offer a terse response. 1.15. What is the ratio of the % of GDP of Poland in 2002 to that in 2006?
Give a very brief answer. 0.86. What is the ratio of the % of GDP of Senegal in 2002 to that in 2006?
Your response must be concise. 0.7. What is the ratio of the % of GDP in Arab World in 2002 to that in 2007?
Keep it short and to the point. 0.8. What is the ratio of the % of GDP of Benin in 2002 to that in 2007?
Your answer should be very brief. 0.91. What is the ratio of the % of GDP in Poland in 2002 to that in 2007?
Your answer should be very brief. 0.74. What is the ratio of the % of GDP of Senegal in 2002 to that in 2007?
Offer a very short reply. 0.59. What is the ratio of the % of GDP in Arab World in 2003 to that in 2004?
Your response must be concise. 1.01. What is the ratio of the % of GDP in Poland in 2003 to that in 2004?
Ensure brevity in your answer.  0.93. What is the ratio of the % of GDP in Senegal in 2003 to that in 2004?
Offer a terse response. 1.03. What is the ratio of the % of GDP in Arab World in 2003 to that in 2005?
Your answer should be compact. 1.01. What is the ratio of the % of GDP in Benin in 2003 to that in 2005?
Your response must be concise. 1.24. What is the ratio of the % of GDP of Poland in 2003 to that in 2005?
Offer a terse response. 0.96. What is the ratio of the % of GDP in Senegal in 2003 to that in 2005?
Provide a succinct answer. 0.91. What is the ratio of the % of GDP of Arab World in 2003 to that in 2006?
Give a very brief answer. 0.97. What is the ratio of the % of GDP of Benin in 2003 to that in 2006?
Offer a very short reply. 1.17. What is the ratio of the % of GDP of Poland in 2003 to that in 2006?
Offer a terse response. 0.87. What is the ratio of the % of GDP in Senegal in 2003 to that in 2006?
Give a very brief answer. 0.9. What is the ratio of the % of GDP in Arab World in 2003 to that in 2007?
Provide a short and direct response. 0.82. What is the ratio of the % of GDP of Benin in 2003 to that in 2007?
Give a very brief answer. 0.92. What is the ratio of the % of GDP in Poland in 2003 to that in 2007?
Your answer should be compact. 0.76. What is the ratio of the % of GDP in Senegal in 2003 to that in 2007?
Keep it short and to the point. 0.76. What is the ratio of the % of GDP in Benin in 2004 to that in 2005?
Give a very brief answer. 1.24. What is the ratio of the % of GDP of Senegal in 2004 to that in 2005?
Offer a terse response. 0.88. What is the ratio of the % of GDP of Arab World in 2004 to that in 2006?
Keep it short and to the point. 0.96. What is the ratio of the % of GDP in Benin in 2004 to that in 2006?
Ensure brevity in your answer.  1.17. What is the ratio of the % of GDP in Poland in 2004 to that in 2006?
Make the answer very short. 0.95. What is the ratio of the % of GDP in Senegal in 2004 to that in 2006?
Ensure brevity in your answer.  0.88. What is the ratio of the % of GDP in Arab World in 2004 to that in 2007?
Keep it short and to the point. 0.81. What is the ratio of the % of GDP in Benin in 2004 to that in 2007?
Your response must be concise. 0.92. What is the ratio of the % of GDP of Poland in 2004 to that in 2007?
Provide a short and direct response. 0.82. What is the ratio of the % of GDP in Senegal in 2004 to that in 2007?
Give a very brief answer. 0.74. What is the ratio of the % of GDP in Arab World in 2005 to that in 2006?
Provide a short and direct response. 0.96. What is the ratio of the % of GDP of Benin in 2005 to that in 2006?
Keep it short and to the point. 0.94. What is the ratio of the % of GDP of Poland in 2005 to that in 2006?
Your answer should be very brief. 0.91. What is the ratio of the % of GDP of Senegal in 2005 to that in 2006?
Offer a very short reply. 0.99. What is the ratio of the % of GDP of Arab World in 2005 to that in 2007?
Offer a terse response. 0.81. What is the ratio of the % of GDP of Benin in 2005 to that in 2007?
Give a very brief answer. 0.74. What is the ratio of the % of GDP of Poland in 2005 to that in 2007?
Offer a very short reply. 0.79. What is the ratio of the % of GDP of Senegal in 2005 to that in 2007?
Your answer should be compact. 0.84. What is the ratio of the % of GDP in Arab World in 2006 to that in 2007?
Your answer should be compact. 0.85. What is the ratio of the % of GDP of Benin in 2006 to that in 2007?
Offer a very short reply. 0.79. What is the ratio of the % of GDP of Poland in 2006 to that in 2007?
Ensure brevity in your answer.  0.87. What is the ratio of the % of GDP in Senegal in 2006 to that in 2007?
Offer a very short reply. 0.84. What is the difference between the highest and the second highest % of GDP in Arab World?
Provide a succinct answer. 4.05. What is the difference between the highest and the second highest % of GDP in Benin?
Make the answer very short. 1.98. What is the difference between the highest and the second highest % of GDP of Poland?
Offer a very short reply. 0.21. What is the difference between the highest and the second highest % of GDP in Senegal?
Provide a succinct answer. 4.55. What is the difference between the highest and the lowest % of GDP of Arab World?
Ensure brevity in your answer.  7.14. What is the difference between the highest and the lowest % of GDP of Benin?
Your answer should be very brief. 8.25. What is the difference between the highest and the lowest % of GDP in Poland?
Your answer should be compact. 6.35. What is the difference between the highest and the lowest % of GDP of Senegal?
Offer a terse response. 12.08. 